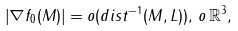Convert formula to latex. <formula><loc_0><loc_0><loc_500><loc_500>\left | \nabla f _ { 0 } ( M ) \right | = o ( d i s t ^ { - 1 } ( M , L ) ) , \, o \, \mathbb { R } ^ { 3 } ,</formula> 